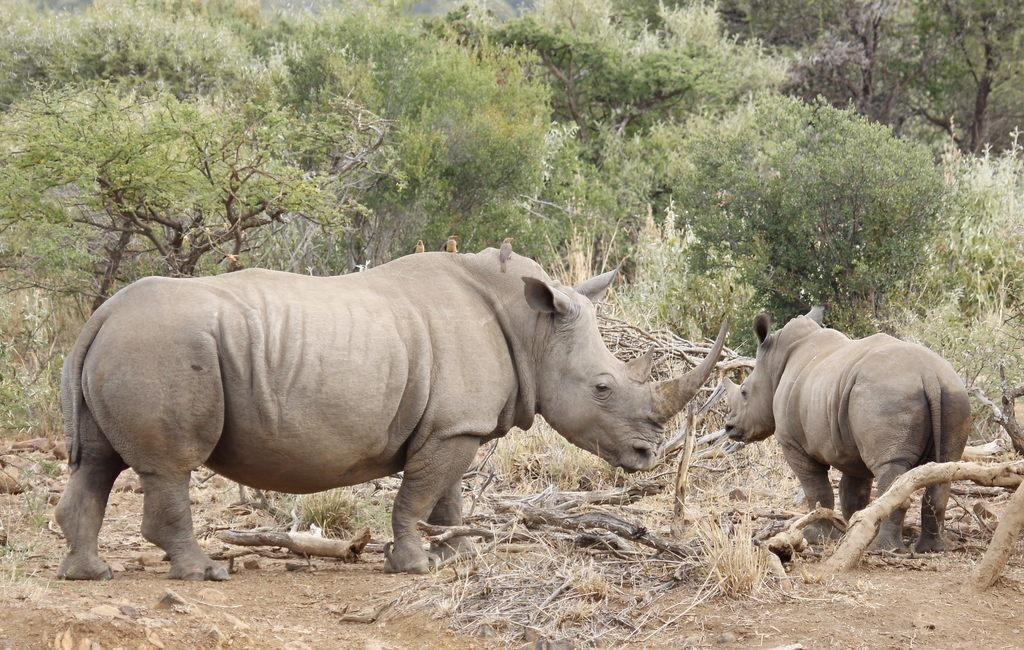How many rhinoceros are in the image? There are two rhinoceros in the image. What is the position of the rhinoceros in the image? The rhinoceros are standing on the ground. What can be seen in the background of the image? There are many trees in the background of the image. What type of material is visible at the bottom of the image? Wood is visible at the bottom of the image. What type of vegetation is present at the bottom of the image? Dry grass is present at the bottom of the image. What sound do the rhinoceros make as they run through the image? The rhinoceros are not running in the image, and there is no sound present in the image. 